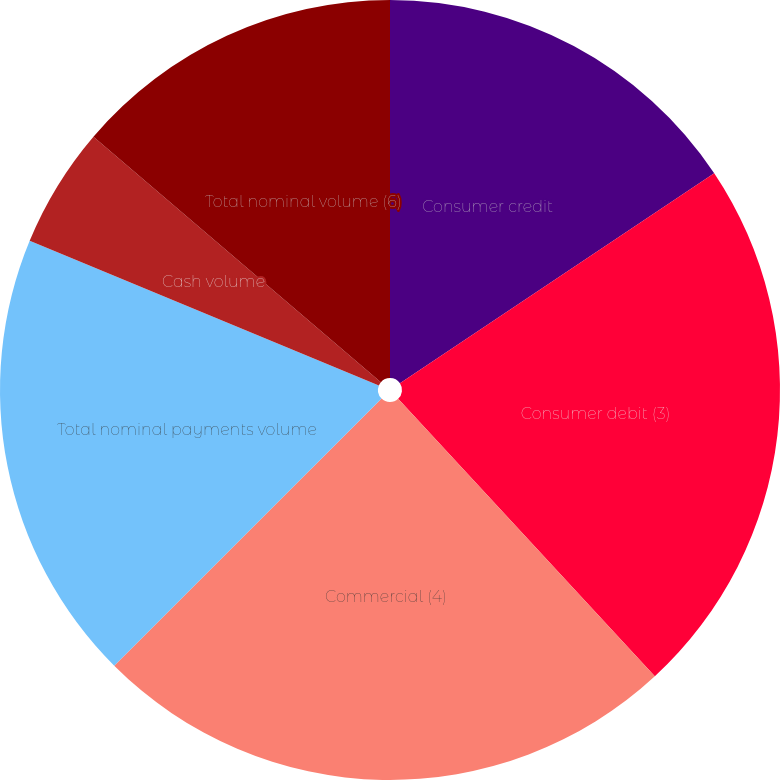Convert chart to OTSL. <chart><loc_0><loc_0><loc_500><loc_500><pie_chart><fcel>Consumer credit<fcel>Consumer debit (3)<fcel>Commercial (4)<fcel>Total nominal payments volume<fcel>Cash volume<fcel>Total nominal volume (6)<nl><fcel>15.62%<fcel>22.5%<fcel>24.38%<fcel>18.75%<fcel>5.0%<fcel>13.75%<nl></chart> 